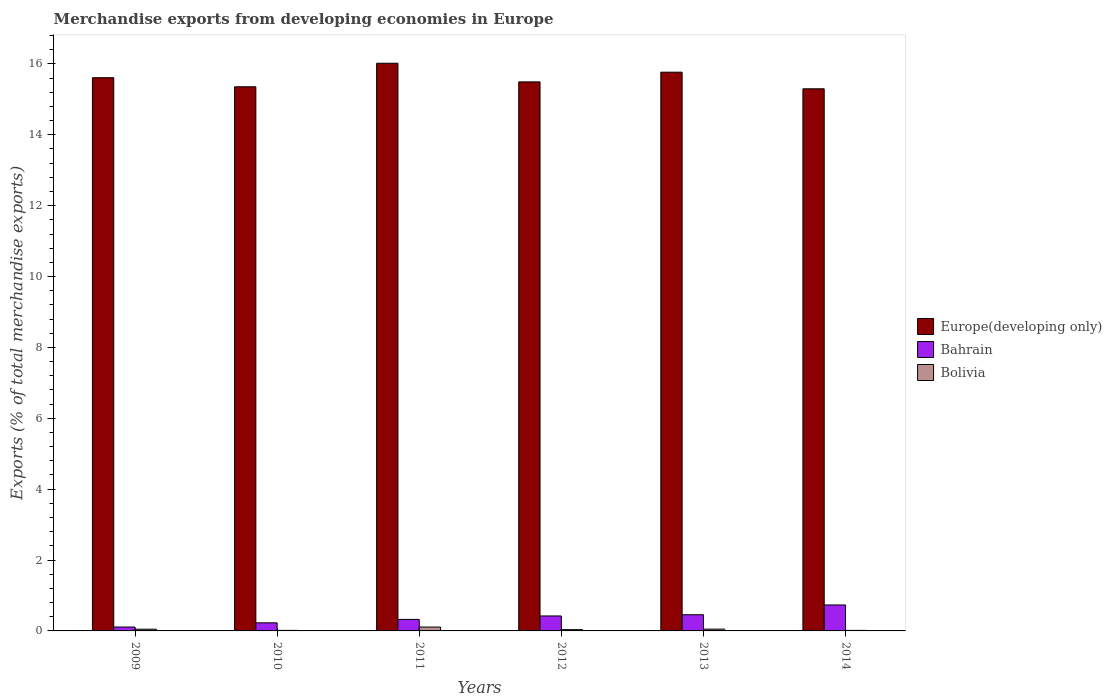How many different coloured bars are there?
Your answer should be very brief. 3. How many groups of bars are there?
Offer a very short reply. 6. Are the number of bars per tick equal to the number of legend labels?
Your answer should be compact. Yes. Are the number of bars on each tick of the X-axis equal?
Your answer should be compact. Yes. How many bars are there on the 3rd tick from the left?
Make the answer very short. 3. What is the label of the 1st group of bars from the left?
Make the answer very short. 2009. In how many cases, is the number of bars for a given year not equal to the number of legend labels?
Keep it short and to the point. 0. What is the percentage of total merchandise exports in Bolivia in 2011?
Your response must be concise. 0.11. Across all years, what is the maximum percentage of total merchandise exports in Europe(developing only)?
Your answer should be very brief. 16.02. Across all years, what is the minimum percentage of total merchandise exports in Europe(developing only)?
Your answer should be compact. 15.3. In which year was the percentage of total merchandise exports in Europe(developing only) maximum?
Ensure brevity in your answer.  2011. In which year was the percentage of total merchandise exports in Bahrain minimum?
Your answer should be very brief. 2009. What is the total percentage of total merchandise exports in Bahrain in the graph?
Make the answer very short. 2.27. What is the difference between the percentage of total merchandise exports in Bolivia in 2013 and that in 2014?
Your answer should be compact. 0.04. What is the difference between the percentage of total merchandise exports in Bahrain in 2010 and the percentage of total merchandise exports in Bolivia in 2014?
Give a very brief answer. 0.21. What is the average percentage of total merchandise exports in Bolivia per year?
Keep it short and to the point. 0.05. In the year 2014, what is the difference between the percentage of total merchandise exports in Bahrain and percentage of total merchandise exports in Europe(developing only)?
Offer a terse response. -14.56. In how many years, is the percentage of total merchandise exports in Europe(developing only) greater than 5.6 %?
Your answer should be compact. 6. What is the ratio of the percentage of total merchandise exports in Bahrain in 2012 to that in 2014?
Your answer should be compact. 0.58. Is the difference between the percentage of total merchandise exports in Bahrain in 2009 and 2010 greater than the difference between the percentage of total merchandise exports in Europe(developing only) in 2009 and 2010?
Your response must be concise. No. What is the difference between the highest and the second highest percentage of total merchandise exports in Bahrain?
Make the answer very short. 0.28. What is the difference between the highest and the lowest percentage of total merchandise exports in Bahrain?
Ensure brevity in your answer.  0.62. What does the 3rd bar from the left in 2014 represents?
Give a very brief answer. Bolivia. What does the 2nd bar from the right in 2013 represents?
Offer a terse response. Bahrain. What is the difference between two consecutive major ticks on the Y-axis?
Offer a terse response. 2. Are the values on the major ticks of Y-axis written in scientific E-notation?
Provide a short and direct response. No. Does the graph contain grids?
Offer a very short reply. No. Where does the legend appear in the graph?
Offer a very short reply. Center right. How are the legend labels stacked?
Provide a short and direct response. Vertical. What is the title of the graph?
Your answer should be compact. Merchandise exports from developing economies in Europe. Does "Low income" appear as one of the legend labels in the graph?
Your response must be concise. No. What is the label or title of the X-axis?
Provide a short and direct response. Years. What is the label or title of the Y-axis?
Offer a terse response. Exports (% of total merchandise exports). What is the Exports (% of total merchandise exports) in Europe(developing only) in 2009?
Keep it short and to the point. 15.61. What is the Exports (% of total merchandise exports) in Bahrain in 2009?
Your response must be concise. 0.11. What is the Exports (% of total merchandise exports) of Bolivia in 2009?
Provide a succinct answer. 0.05. What is the Exports (% of total merchandise exports) of Europe(developing only) in 2010?
Make the answer very short. 15.35. What is the Exports (% of total merchandise exports) in Bahrain in 2010?
Ensure brevity in your answer.  0.23. What is the Exports (% of total merchandise exports) of Bolivia in 2010?
Give a very brief answer. 0.02. What is the Exports (% of total merchandise exports) in Europe(developing only) in 2011?
Ensure brevity in your answer.  16.02. What is the Exports (% of total merchandise exports) of Bahrain in 2011?
Give a very brief answer. 0.33. What is the Exports (% of total merchandise exports) of Bolivia in 2011?
Give a very brief answer. 0.11. What is the Exports (% of total merchandise exports) of Europe(developing only) in 2012?
Offer a very short reply. 15.49. What is the Exports (% of total merchandise exports) of Bahrain in 2012?
Offer a very short reply. 0.42. What is the Exports (% of total merchandise exports) in Bolivia in 2012?
Provide a short and direct response. 0.04. What is the Exports (% of total merchandise exports) in Europe(developing only) in 2013?
Offer a very short reply. 15.77. What is the Exports (% of total merchandise exports) in Bahrain in 2013?
Keep it short and to the point. 0.46. What is the Exports (% of total merchandise exports) in Bolivia in 2013?
Offer a terse response. 0.05. What is the Exports (% of total merchandise exports) in Europe(developing only) in 2014?
Offer a terse response. 15.3. What is the Exports (% of total merchandise exports) in Bahrain in 2014?
Ensure brevity in your answer.  0.73. What is the Exports (% of total merchandise exports) in Bolivia in 2014?
Ensure brevity in your answer.  0.02. Across all years, what is the maximum Exports (% of total merchandise exports) of Europe(developing only)?
Provide a succinct answer. 16.02. Across all years, what is the maximum Exports (% of total merchandise exports) in Bahrain?
Make the answer very short. 0.73. Across all years, what is the maximum Exports (% of total merchandise exports) in Bolivia?
Provide a short and direct response. 0.11. Across all years, what is the minimum Exports (% of total merchandise exports) of Europe(developing only)?
Provide a succinct answer. 15.3. Across all years, what is the minimum Exports (% of total merchandise exports) of Bahrain?
Keep it short and to the point. 0.11. Across all years, what is the minimum Exports (% of total merchandise exports) in Bolivia?
Your answer should be compact. 0.02. What is the total Exports (% of total merchandise exports) of Europe(developing only) in the graph?
Ensure brevity in your answer.  93.54. What is the total Exports (% of total merchandise exports) of Bahrain in the graph?
Offer a terse response. 2.27. What is the total Exports (% of total merchandise exports) of Bolivia in the graph?
Your answer should be very brief. 0.27. What is the difference between the Exports (% of total merchandise exports) in Europe(developing only) in 2009 and that in 2010?
Offer a very short reply. 0.26. What is the difference between the Exports (% of total merchandise exports) in Bahrain in 2009 and that in 2010?
Provide a short and direct response. -0.12. What is the difference between the Exports (% of total merchandise exports) in Bolivia in 2009 and that in 2010?
Offer a very short reply. 0.03. What is the difference between the Exports (% of total merchandise exports) of Europe(developing only) in 2009 and that in 2011?
Make the answer very short. -0.41. What is the difference between the Exports (% of total merchandise exports) in Bahrain in 2009 and that in 2011?
Offer a very short reply. -0.22. What is the difference between the Exports (% of total merchandise exports) in Bolivia in 2009 and that in 2011?
Make the answer very short. -0.06. What is the difference between the Exports (% of total merchandise exports) of Europe(developing only) in 2009 and that in 2012?
Offer a terse response. 0.12. What is the difference between the Exports (% of total merchandise exports) in Bahrain in 2009 and that in 2012?
Ensure brevity in your answer.  -0.31. What is the difference between the Exports (% of total merchandise exports) of Bolivia in 2009 and that in 2012?
Your answer should be compact. 0.01. What is the difference between the Exports (% of total merchandise exports) in Europe(developing only) in 2009 and that in 2013?
Ensure brevity in your answer.  -0.16. What is the difference between the Exports (% of total merchandise exports) of Bahrain in 2009 and that in 2013?
Make the answer very short. -0.35. What is the difference between the Exports (% of total merchandise exports) in Bolivia in 2009 and that in 2013?
Provide a succinct answer. -0. What is the difference between the Exports (% of total merchandise exports) of Europe(developing only) in 2009 and that in 2014?
Ensure brevity in your answer.  0.31. What is the difference between the Exports (% of total merchandise exports) of Bahrain in 2009 and that in 2014?
Offer a very short reply. -0.62. What is the difference between the Exports (% of total merchandise exports) of Europe(developing only) in 2010 and that in 2011?
Provide a succinct answer. -0.66. What is the difference between the Exports (% of total merchandise exports) in Bahrain in 2010 and that in 2011?
Offer a terse response. -0.1. What is the difference between the Exports (% of total merchandise exports) in Bolivia in 2010 and that in 2011?
Your answer should be very brief. -0.09. What is the difference between the Exports (% of total merchandise exports) in Europe(developing only) in 2010 and that in 2012?
Offer a very short reply. -0.14. What is the difference between the Exports (% of total merchandise exports) of Bahrain in 2010 and that in 2012?
Offer a terse response. -0.19. What is the difference between the Exports (% of total merchandise exports) in Bolivia in 2010 and that in 2012?
Offer a very short reply. -0.02. What is the difference between the Exports (% of total merchandise exports) in Europe(developing only) in 2010 and that in 2013?
Your response must be concise. -0.41. What is the difference between the Exports (% of total merchandise exports) of Bahrain in 2010 and that in 2013?
Give a very brief answer. -0.23. What is the difference between the Exports (% of total merchandise exports) in Bolivia in 2010 and that in 2013?
Your answer should be very brief. -0.04. What is the difference between the Exports (% of total merchandise exports) in Europe(developing only) in 2010 and that in 2014?
Your answer should be very brief. 0.06. What is the difference between the Exports (% of total merchandise exports) of Bahrain in 2010 and that in 2014?
Ensure brevity in your answer.  -0.5. What is the difference between the Exports (% of total merchandise exports) in Bolivia in 2010 and that in 2014?
Your answer should be very brief. -0. What is the difference between the Exports (% of total merchandise exports) of Europe(developing only) in 2011 and that in 2012?
Provide a succinct answer. 0.53. What is the difference between the Exports (% of total merchandise exports) in Bahrain in 2011 and that in 2012?
Provide a succinct answer. -0.1. What is the difference between the Exports (% of total merchandise exports) of Bolivia in 2011 and that in 2012?
Keep it short and to the point. 0.07. What is the difference between the Exports (% of total merchandise exports) in Europe(developing only) in 2011 and that in 2013?
Offer a terse response. 0.25. What is the difference between the Exports (% of total merchandise exports) of Bahrain in 2011 and that in 2013?
Provide a succinct answer. -0.13. What is the difference between the Exports (% of total merchandise exports) of Bolivia in 2011 and that in 2013?
Make the answer very short. 0.06. What is the difference between the Exports (% of total merchandise exports) in Europe(developing only) in 2011 and that in 2014?
Provide a succinct answer. 0.72. What is the difference between the Exports (% of total merchandise exports) in Bahrain in 2011 and that in 2014?
Give a very brief answer. -0.41. What is the difference between the Exports (% of total merchandise exports) in Bolivia in 2011 and that in 2014?
Your response must be concise. 0.09. What is the difference between the Exports (% of total merchandise exports) of Europe(developing only) in 2012 and that in 2013?
Offer a terse response. -0.27. What is the difference between the Exports (% of total merchandise exports) in Bahrain in 2012 and that in 2013?
Offer a very short reply. -0.03. What is the difference between the Exports (% of total merchandise exports) in Bolivia in 2012 and that in 2013?
Provide a short and direct response. -0.01. What is the difference between the Exports (% of total merchandise exports) of Europe(developing only) in 2012 and that in 2014?
Your answer should be very brief. 0.2. What is the difference between the Exports (% of total merchandise exports) in Bahrain in 2012 and that in 2014?
Make the answer very short. -0.31. What is the difference between the Exports (% of total merchandise exports) in Bolivia in 2012 and that in 2014?
Offer a terse response. 0.02. What is the difference between the Exports (% of total merchandise exports) in Europe(developing only) in 2013 and that in 2014?
Keep it short and to the point. 0.47. What is the difference between the Exports (% of total merchandise exports) in Bahrain in 2013 and that in 2014?
Provide a succinct answer. -0.28. What is the difference between the Exports (% of total merchandise exports) of Bolivia in 2013 and that in 2014?
Ensure brevity in your answer.  0.04. What is the difference between the Exports (% of total merchandise exports) in Europe(developing only) in 2009 and the Exports (% of total merchandise exports) in Bahrain in 2010?
Provide a succinct answer. 15.38. What is the difference between the Exports (% of total merchandise exports) of Europe(developing only) in 2009 and the Exports (% of total merchandise exports) of Bolivia in 2010?
Provide a short and direct response. 15.59. What is the difference between the Exports (% of total merchandise exports) in Bahrain in 2009 and the Exports (% of total merchandise exports) in Bolivia in 2010?
Your answer should be very brief. 0.09. What is the difference between the Exports (% of total merchandise exports) in Europe(developing only) in 2009 and the Exports (% of total merchandise exports) in Bahrain in 2011?
Ensure brevity in your answer.  15.28. What is the difference between the Exports (% of total merchandise exports) in Europe(developing only) in 2009 and the Exports (% of total merchandise exports) in Bolivia in 2011?
Keep it short and to the point. 15.5. What is the difference between the Exports (% of total merchandise exports) in Bahrain in 2009 and the Exports (% of total merchandise exports) in Bolivia in 2011?
Offer a terse response. 0. What is the difference between the Exports (% of total merchandise exports) of Europe(developing only) in 2009 and the Exports (% of total merchandise exports) of Bahrain in 2012?
Ensure brevity in your answer.  15.19. What is the difference between the Exports (% of total merchandise exports) in Europe(developing only) in 2009 and the Exports (% of total merchandise exports) in Bolivia in 2012?
Provide a succinct answer. 15.57. What is the difference between the Exports (% of total merchandise exports) in Bahrain in 2009 and the Exports (% of total merchandise exports) in Bolivia in 2012?
Make the answer very short. 0.07. What is the difference between the Exports (% of total merchandise exports) of Europe(developing only) in 2009 and the Exports (% of total merchandise exports) of Bahrain in 2013?
Keep it short and to the point. 15.15. What is the difference between the Exports (% of total merchandise exports) of Europe(developing only) in 2009 and the Exports (% of total merchandise exports) of Bolivia in 2013?
Ensure brevity in your answer.  15.56. What is the difference between the Exports (% of total merchandise exports) of Bahrain in 2009 and the Exports (% of total merchandise exports) of Bolivia in 2013?
Keep it short and to the point. 0.06. What is the difference between the Exports (% of total merchandise exports) of Europe(developing only) in 2009 and the Exports (% of total merchandise exports) of Bahrain in 2014?
Provide a succinct answer. 14.88. What is the difference between the Exports (% of total merchandise exports) of Europe(developing only) in 2009 and the Exports (% of total merchandise exports) of Bolivia in 2014?
Ensure brevity in your answer.  15.59. What is the difference between the Exports (% of total merchandise exports) of Bahrain in 2009 and the Exports (% of total merchandise exports) of Bolivia in 2014?
Offer a very short reply. 0.09. What is the difference between the Exports (% of total merchandise exports) in Europe(developing only) in 2010 and the Exports (% of total merchandise exports) in Bahrain in 2011?
Provide a short and direct response. 15.03. What is the difference between the Exports (% of total merchandise exports) in Europe(developing only) in 2010 and the Exports (% of total merchandise exports) in Bolivia in 2011?
Make the answer very short. 15.24. What is the difference between the Exports (% of total merchandise exports) of Bahrain in 2010 and the Exports (% of total merchandise exports) of Bolivia in 2011?
Offer a very short reply. 0.12. What is the difference between the Exports (% of total merchandise exports) of Europe(developing only) in 2010 and the Exports (% of total merchandise exports) of Bahrain in 2012?
Your answer should be compact. 14.93. What is the difference between the Exports (% of total merchandise exports) in Europe(developing only) in 2010 and the Exports (% of total merchandise exports) in Bolivia in 2012?
Make the answer very short. 15.32. What is the difference between the Exports (% of total merchandise exports) of Bahrain in 2010 and the Exports (% of total merchandise exports) of Bolivia in 2012?
Provide a succinct answer. 0.19. What is the difference between the Exports (% of total merchandise exports) of Europe(developing only) in 2010 and the Exports (% of total merchandise exports) of Bahrain in 2013?
Your answer should be very brief. 14.9. What is the difference between the Exports (% of total merchandise exports) in Europe(developing only) in 2010 and the Exports (% of total merchandise exports) in Bolivia in 2013?
Keep it short and to the point. 15.3. What is the difference between the Exports (% of total merchandise exports) of Bahrain in 2010 and the Exports (% of total merchandise exports) of Bolivia in 2013?
Offer a very short reply. 0.18. What is the difference between the Exports (% of total merchandise exports) in Europe(developing only) in 2010 and the Exports (% of total merchandise exports) in Bahrain in 2014?
Your response must be concise. 14.62. What is the difference between the Exports (% of total merchandise exports) of Europe(developing only) in 2010 and the Exports (% of total merchandise exports) of Bolivia in 2014?
Your answer should be compact. 15.34. What is the difference between the Exports (% of total merchandise exports) in Bahrain in 2010 and the Exports (% of total merchandise exports) in Bolivia in 2014?
Your answer should be very brief. 0.21. What is the difference between the Exports (% of total merchandise exports) in Europe(developing only) in 2011 and the Exports (% of total merchandise exports) in Bahrain in 2012?
Provide a succinct answer. 15.6. What is the difference between the Exports (% of total merchandise exports) of Europe(developing only) in 2011 and the Exports (% of total merchandise exports) of Bolivia in 2012?
Your response must be concise. 15.98. What is the difference between the Exports (% of total merchandise exports) in Bahrain in 2011 and the Exports (% of total merchandise exports) in Bolivia in 2012?
Your answer should be very brief. 0.29. What is the difference between the Exports (% of total merchandise exports) in Europe(developing only) in 2011 and the Exports (% of total merchandise exports) in Bahrain in 2013?
Keep it short and to the point. 15.56. What is the difference between the Exports (% of total merchandise exports) in Europe(developing only) in 2011 and the Exports (% of total merchandise exports) in Bolivia in 2013?
Your response must be concise. 15.97. What is the difference between the Exports (% of total merchandise exports) of Bahrain in 2011 and the Exports (% of total merchandise exports) of Bolivia in 2013?
Ensure brevity in your answer.  0.27. What is the difference between the Exports (% of total merchandise exports) of Europe(developing only) in 2011 and the Exports (% of total merchandise exports) of Bahrain in 2014?
Keep it short and to the point. 15.29. What is the difference between the Exports (% of total merchandise exports) in Europe(developing only) in 2011 and the Exports (% of total merchandise exports) in Bolivia in 2014?
Keep it short and to the point. 16. What is the difference between the Exports (% of total merchandise exports) in Bahrain in 2011 and the Exports (% of total merchandise exports) in Bolivia in 2014?
Your answer should be compact. 0.31. What is the difference between the Exports (% of total merchandise exports) of Europe(developing only) in 2012 and the Exports (% of total merchandise exports) of Bahrain in 2013?
Make the answer very short. 15.04. What is the difference between the Exports (% of total merchandise exports) in Europe(developing only) in 2012 and the Exports (% of total merchandise exports) in Bolivia in 2013?
Provide a short and direct response. 15.44. What is the difference between the Exports (% of total merchandise exports) of Bahrain in 2012 and the Exports (% of total merchandise exports) of Bolivia in 2013?
Make the answer very short. 0.37. What is the difference between the Exports (% of total merchandise exports) in Europe(developing only) in 2012 and the Exports (% of total merchandise exports) in Bahrain in 2014?
Provide a short and direct response. 14.76. What is the difference between the Exports (% of total merchandise exports) of Europe(developing only) in 2012 and the Exports (% of total merchandise exports) of Bolivia in 2014?
Make the answer very short. 15.48. What is the difference between the Exports (% of total merchandise exports) of Bahrain in 2012 and the Exports (% of total merchandise exports) of Bolivia in 2014?
Give a very brief answer. 0.41. What is the difference between the Exports (% of total merchandise exports) in Europe(developing only) in 2013 and the Exports (% of total merchandise exports) in Bahrain in 2014?
Your response must be concise. 15.03. What is the difference between the Exports (% of total merchandise exports) in Europe(developing only) in 2013 and the Exports (% of total merchandise exports) in Bolivia in 2014?
Offer a very short reply. 15.75. What is the difference between the Exports (% of total merchandise exports) of Bahrain in 2013 and the Exports (% of total merchandise exports) of Bolivia in 2014?
Offer a terse response. 0.44. What is the average Exports (% of total merchandise exports) of Europe(developing only) per year?
Your answer should be very brief. 15.59. What is the average Exports (% of total merchandise exports) in Bahrain per year?
Ensure brevity in your answer.  0.38. What is the average Exports (% of total merchandise exports) in Bolivia per year?
Your response must be concise. 0.05. In the year 2009, what is the difference between the Exports (% of total merchandise exports) in Europe(developing only) and Exports (% of total merchandise exports) in Bahrain?
Keep it short and to the point. 15.5. In the year 2009, what is the difference between the Exports (% of total merchandise exports) in Europe(developing only) and Exports (% of total merchandise exports) in Bolivia?
Your answer should be compact. 15.56. In the year 2009, what is the difference between the Exports (% of total merchandise exports) in Bahrain and Exports (% of total merchandise exports) in Bolivia?
Offer a very short reply. 0.06. In the year 2010, what is the difference between the Exports (% of total merchandise exports) in Europe(developing only) and Exports (% of total merchandise exports) in Bahrain?
Ensure brevity in your answer.  15.13. In the year 2010, what is the difference between the Exports (% of total merchandise exports) in Europe(developing only) and Exports (% of total merchandise exports) in Bolivia?
Ensure brevity in your answer.  15.34. In the year 2010, what is the difference between the Exports (% of total merchandise exports) in Bahrain and Exports (% of total merchandise exports) in Bolivia?
Offer a very short reply. 0.21. In the year 2011, what is the difference between the Exports (% of total merchandise exports) of Europe(developing only) and Exports (% of total merchandise exports) of Bahrain?
Keep it short and to the point. 15.69. In the year 2011, what is the difference between the Exports (% of total merchandise exports) of Europe(developing only) and Exports (% of total merchandise exports) of Bolivia?
Offer a terse response. 15.91. In the year 2011, what is the difference between the Exports (% of total merchandise exports) of Bahrain and Exports (% of total merchandise exports) of Bolivia?
Provide a succinct answer. 0.22. In the year 2012, what is the difference between the Exports (% of total merchandise exports) in Europe(developing only) and Exports (% of total merchandise exports) in Bahrain?
Ensure brevity in your answer.  15.07. In the year 2012, what is the difference between the Exports (% of total merchandise exports) in Europe(developing only) and Exports (% of total merchandise exports) in Bolivia?
Provide a short and direct response. 15.46. In the year 2012, what is the difference between the Exports (% of total merchandise exports) of Bahrain and Exports (% of total merchandise exports) of Bolivia?
Ensure brevity in your answer.  0.39. In the year 2013, what is the difference between the Exports (% of total merchandise exports) in Europe(developing only) and Exports (% of total merchandise exports) in Bahrain?
Your answer should be compact. 15.31. In the year 2013, what is the difference between the Exports (% of total merchandise exports) of Europe(developing only) and Exports (% of total merchandise exports) of Bolivia?
Provide a succinct answer. 15.72. In the year 2013, what is the difference between the Exports (% of total merchandise exports) of Bahrain and Exports (% of total merchandise exports) of Bolivia?
Provide a short and direct response. 0.41. In the year 2014, what is the difference between the Exports (% of total merchandise exports) in Europe(developing only) and Exports (% of total merchandise exports) in Bahrain?
Offer a terse response. 14.56. In the year 2014, what is the difference between the Exports (% of total merchandise exports) in Europe(developing only) and Exports (% of total merchandise exports) in Bolivia?
Provide a short and direct response. 15.28. In the year 2014, what is the difference between the Exports (% of total merchandise exports) of Bahrain and Exports (% of total merchandise exports) of Bolivia?
Your answer should be compact. 0.72. What is the ratio of the Exports (% of total merchandise exports) of Europe(developing only) in 2009 to that in 2010?
Your answer should be compact. 1.02. What is the ratio of the Exports (% of total merchandise exports) of Bahrain in 2009 to that in 2010?
Keep it short and to the point. 0.48. What is the ratio of the Exports (% of total merchandise exports) in Bolivia in 2009 to that in 2010?
Offer a very short reply. 3.21. What is the ratio of the Exports (% of total merchandise exports) in Europe(developing only) in 2009 to that in 2011?
Your answer should be compact. 0.97. What is the ratio of the Exports (% of total merchandise exports) in Bahrain in 2009 to that in 2011?
Offer a terse response. 0.34. What is the ratio of the Exports (% of total merchandise exports) in Bolivia in 2009 to that in 2011?
Offer a very short reply. 0.44. What is the ratio of the Exports (% of total merchandise exports) of Europe(developing only) in 2009 to that in 2012?
Your answer should be very brief. 1.01. What is the ratio of the Exports (% of total merchandise exports) of Bahrain in 2009 to that in 2012?
Your answer should be compact. 0.26. What is the ratio of the Exports (% of total merchandise exports) in Bolivia in 2009 to that in 2012?
Offer a terse response. 1.36. What is the ratio of the Exports (% of total merchandise exports) of Europe(developing only) in 2009 to that in 2013?
Offer a terse response. 0.99. What is the ratio of the Exports (% of total merchandise exports) in Bahrain in 2009 to that in 2013?
Give a very brief answer. 0.24. What is the ratio of the Exports (% of total merchandise exports) of Bolivia in 2009 to that in 2013?
Ensure brevity in your answer.  0.96. What is the ratio of the Exports (% of total merchandise exports) in Europe(developing only) in 2009 to that in 2014?
Your answer should be very brief. 1.02. What is the ratio of the Exports (% of total merchandise exports) of Bahrain in 2009 to that in 2014?
Make the answer very short. 0.15. What is the ratio of the Exports (% of total merchandise exports) of Bolivia in 2009 to that in 2014?
Make the answer very short. 3.18. What is the ratio of the Exports (% of total merchandise exports) of Europe(developing only) in 2010 to that in 2011?
Provide a succinct answer. 0.96. What is the ratio of the Exports (% of total merchandise exports) of Bahrain in 2010 to that in 2011?
Your answer should be very brief. 0.7. What is the ratio of the Exports (% of total merchandise exports) in Bolivia in 2010 to that in 2011?
Offer a very short reply. 0.14. What is the ratio of the Exports (% of total merchandise exports) of Bahrain in 2010 to that in 2012?
Ensure brevity in your answer.  0.54. What is the ratio of the Exports (% of total merchandise exports) in Bolivia in 2010 to that in 2012?
Give a very brief answer. 0.42. What is the ratio of the Exports (% of total merchandise exports) of Europe(developing only) in 2010 to that in 2013?
Your response must be concise. 0.97. What is the ratio of the Exports (% of total merchandise exports) of Bahrain in 2010 to that in 2013?
Your response must be concise. 0.5. What is the ratio of the Exports (% of total merchandise exports) of Europe(developing only) in 2010 to that in 2014?
Provide a short and direct response. 1. What is the ratio of the Exports (% of total merchandise exports) in Bahrain in 2010 to that in 2014?
Offer a terse response. 0.31. What is the ratio of the Exports (% of total merchandise exports) of Bolivia in 2010 to that in 2014?
Your answer should be very brief. 0.99. What is the ratio of the Exports (% of total merchandise exports) of Europe(developing only) in 2011 to that in 2012?
Offer a very short reply. 1.03. What is the ratio of the Exports (% of total merchandise exports) in Bahrain in 2011 to that in 2012?
Your answer should be compact. 0.77. What is the ratio of the Exports (% of total merchandise exports) of Bolivia in 2011 to that in 2012?
Your answer should be compact. 3.06. What is the ratio of the Exports (% of total merchandise exports) of Bahrain in 2011 to that in 2013?
Give a very brief answer. 0.71. What is the ratio of the Exports (% of total merchandise exports) in Bolivia in 2011 to that in 2013?
Offer a very short reply. 2.17. What is the ratio of the Exports (% of total merchandise exports) of Europe(developing only) in 2011 to that in 2014?
Offer a very short reply. 1.05. What is the ratio of the Exports (% of total merchandise exports) in Bahrain in 2011 to that in 2014?
Your response must be concise. 0.44. What is the ratio of the Exports (% of total merchandise exports) in Bolivia in 2011 to that in 2014?
Provide a short and direct response. 7.16. What is the ratio of the Exports (% of total merchandise exports) of Europe(developing only) in 2012 to that in 2013?
Provide a short and direct response. 0.98. What is the ratio of the Exports (% of total merchandise exports) in Bahrain in 2012 to that in 2013?
Provide a short and direct response. 0.92. What is the ratio of the Exports (% of total merchandise exports) of Bolivia in 2012 to that in 2013?
Offer a very short reply. 0.71. What is the ratio of the Exports (% of total merchandise exports) in Europe(developing only) in 2012 to that in 2014?
Give a very brief answer. 1.01. What is the ratio of the Exports (% of total merchandise exports) of Bahrain in 2012 to that in 2014?
Offer a very short reply. 0.58. What is the ratio of the Exports (% of total merchandise exports) in Bolivia in 2012 to that in 2014?
Your response must be concise. 2.34. What is the ratio of the Exports (% of total merchandise exports) in Europe(developing only) in 2013 to that in 2014?
Provide a short and direct response. 1.03. What is the ratio of the Exports (% of total merchandise exports) in Bahrain in 2013 to that in 2014?
Your answer should be compact. 0.62. What is the ratio of the Exports (% of total merchandise exports) of Bolivia in 2013 to that in 2014?
Offer a very short reply. 3.31. What is the difference between the highest and the second highest Exports (% of total merchandise exports) of Europe(developing only)?
Your answer should be very brief. 0.25. What is the difference between the highest and the second highest Exports (% of total merchandise exports) in Bahrain?
Provide a short and direct response. 0.28. What is the difference between the highest and the second highest Exports (% of total merchandise exports) in Bolivia?
Offer a very short reply. 0.06. What is the difference between the highest and the lowest Exports (% of total merchandise exports) of Europe(developing only)?
Offer a very short reply. 0.72. What is the difference between the highest and the lowest Exports (% of total merchandise exports) of Bahrain?
Your response must be concise. 0.62. What is the difference between the highest and the lowest Exports (% of total merchandise exports) of Bolivia?
Your answer should be very brief. 0.09. 